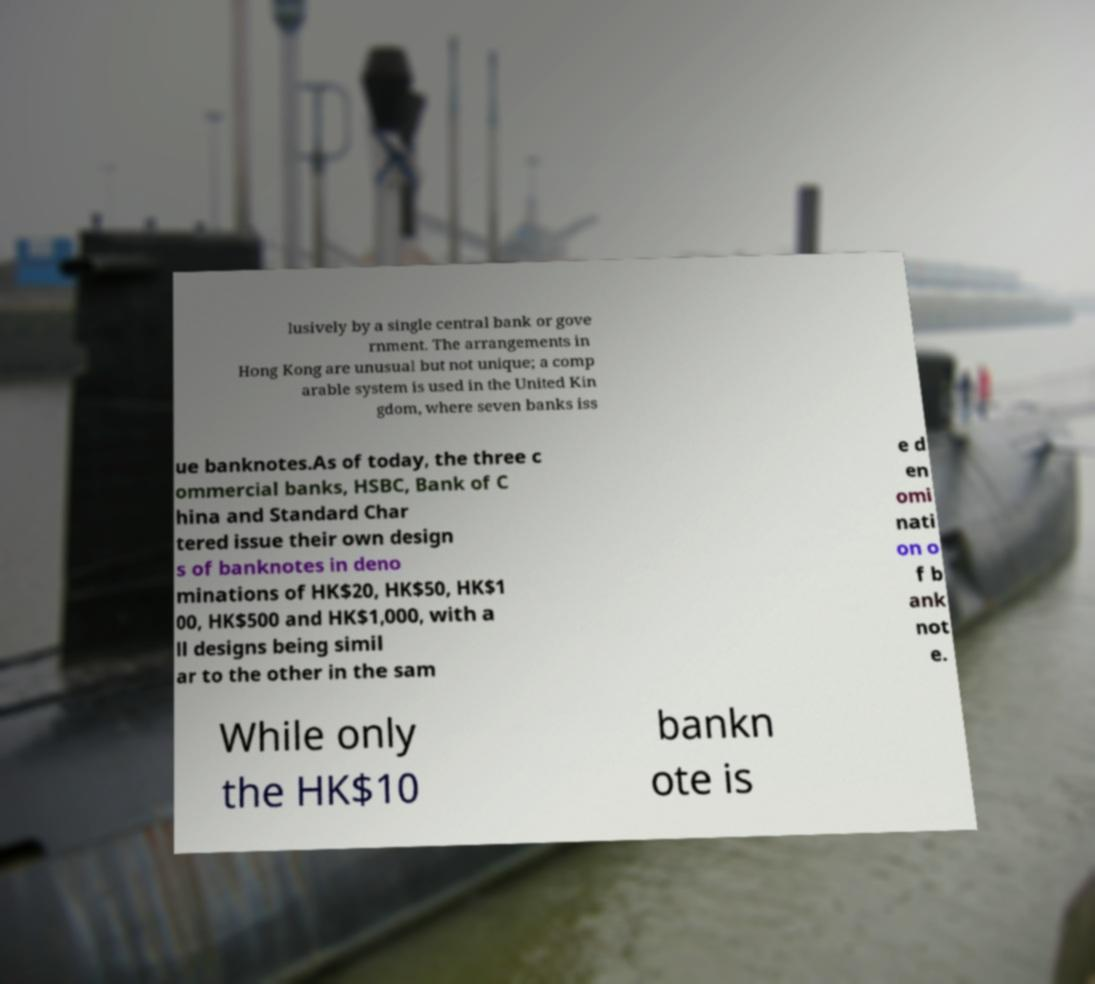Please identify and transcribe the text found in this image. lusively by a single central bank or gove rnment. The arrangements in Hong Kong are unusual but not unique; a comp arable system is used in the United Kin gdom, where seven banks iss ue banknotes.As of today, the three c ommercial banks, HSBC, Bank of C hina and Standard Char tered issue their own design s of banknotes in deno minations of HK$20, HK$50, HK$1 00, HK$500 and HK$1,000, with a ll designs being simil ar to the other in the sam e d en omi nati on o f b ank not e. While only the HK$10 bankn ote is 